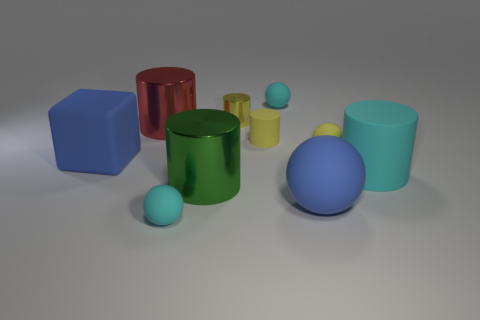There is a big rubber thing that is on the right side of the big ball; is there a tiny yellow metallic cylinder that is right of it?
Ensure brevity in your answer.  No. Do the block in front of the big red shiny cylinder and the big ball on the right side of the rubber block have the same color?
Your answer should be compact. Yes. How many small yellow things are left of the large red metallic cylinder?
Give a very brief answer. 0. What number of shiny things have the same color as the large sphere?
Give a very brief answer. 0. Does the tiny yellow thing behind the red object have the same material as the large green cylinder?
Offer a terse response. Yes. What number of blue spheres have the same material as the big cyan cylinder?
Give a very brief answer. 1. Is the number of cylinders right of the yellow sphere greater than the number of tiny gray metal blocks?
Give a very brief answer. Yes. There is a rubber ball that is the same color as the tiny metal cylinder; what is its size?
Give a very brief answer. Small. Are there any big red objects of the same shape as the small metal object?
Your answer should be very brief. Yes. How many things are either big green things or big rubber spheres?
Make the answer very short. 2. 